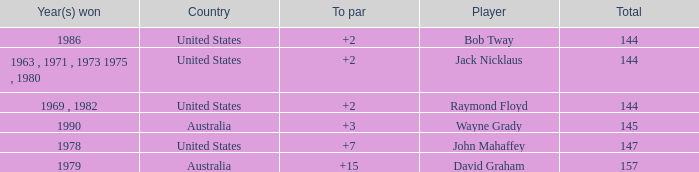What was the average round score of the player who won in 1978? 147.0. 